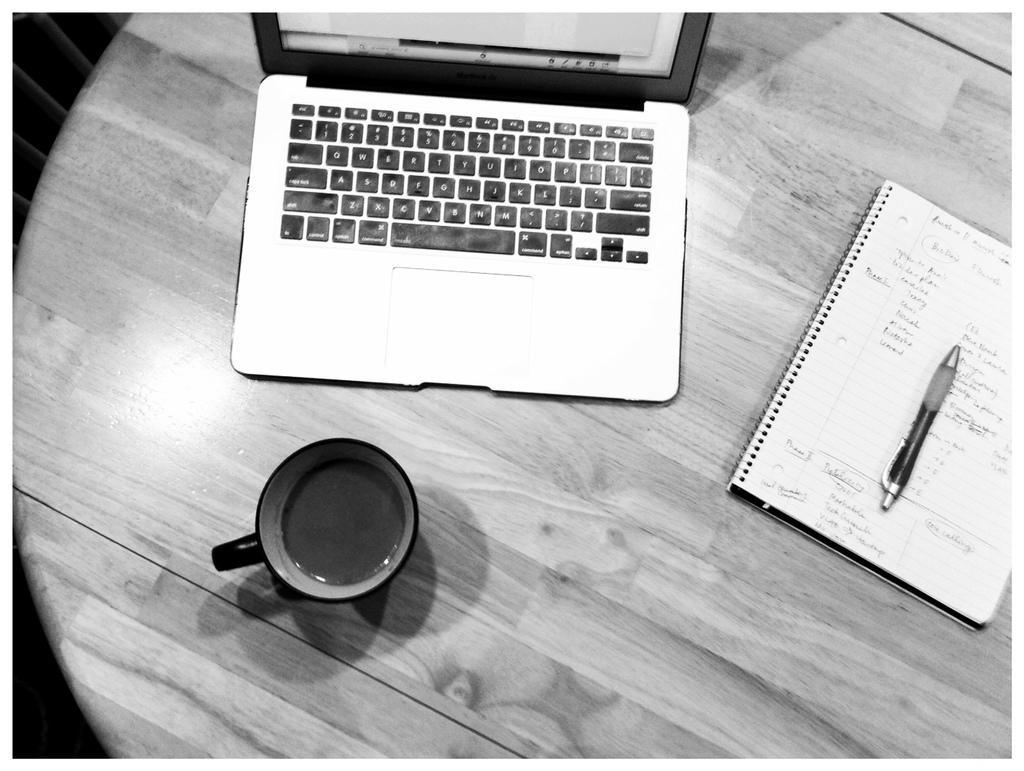Can you describe this image briefly? In this image I can see a laptop on the table. In-front of it there is a coffee cup and beside there is a book with pen on it. 